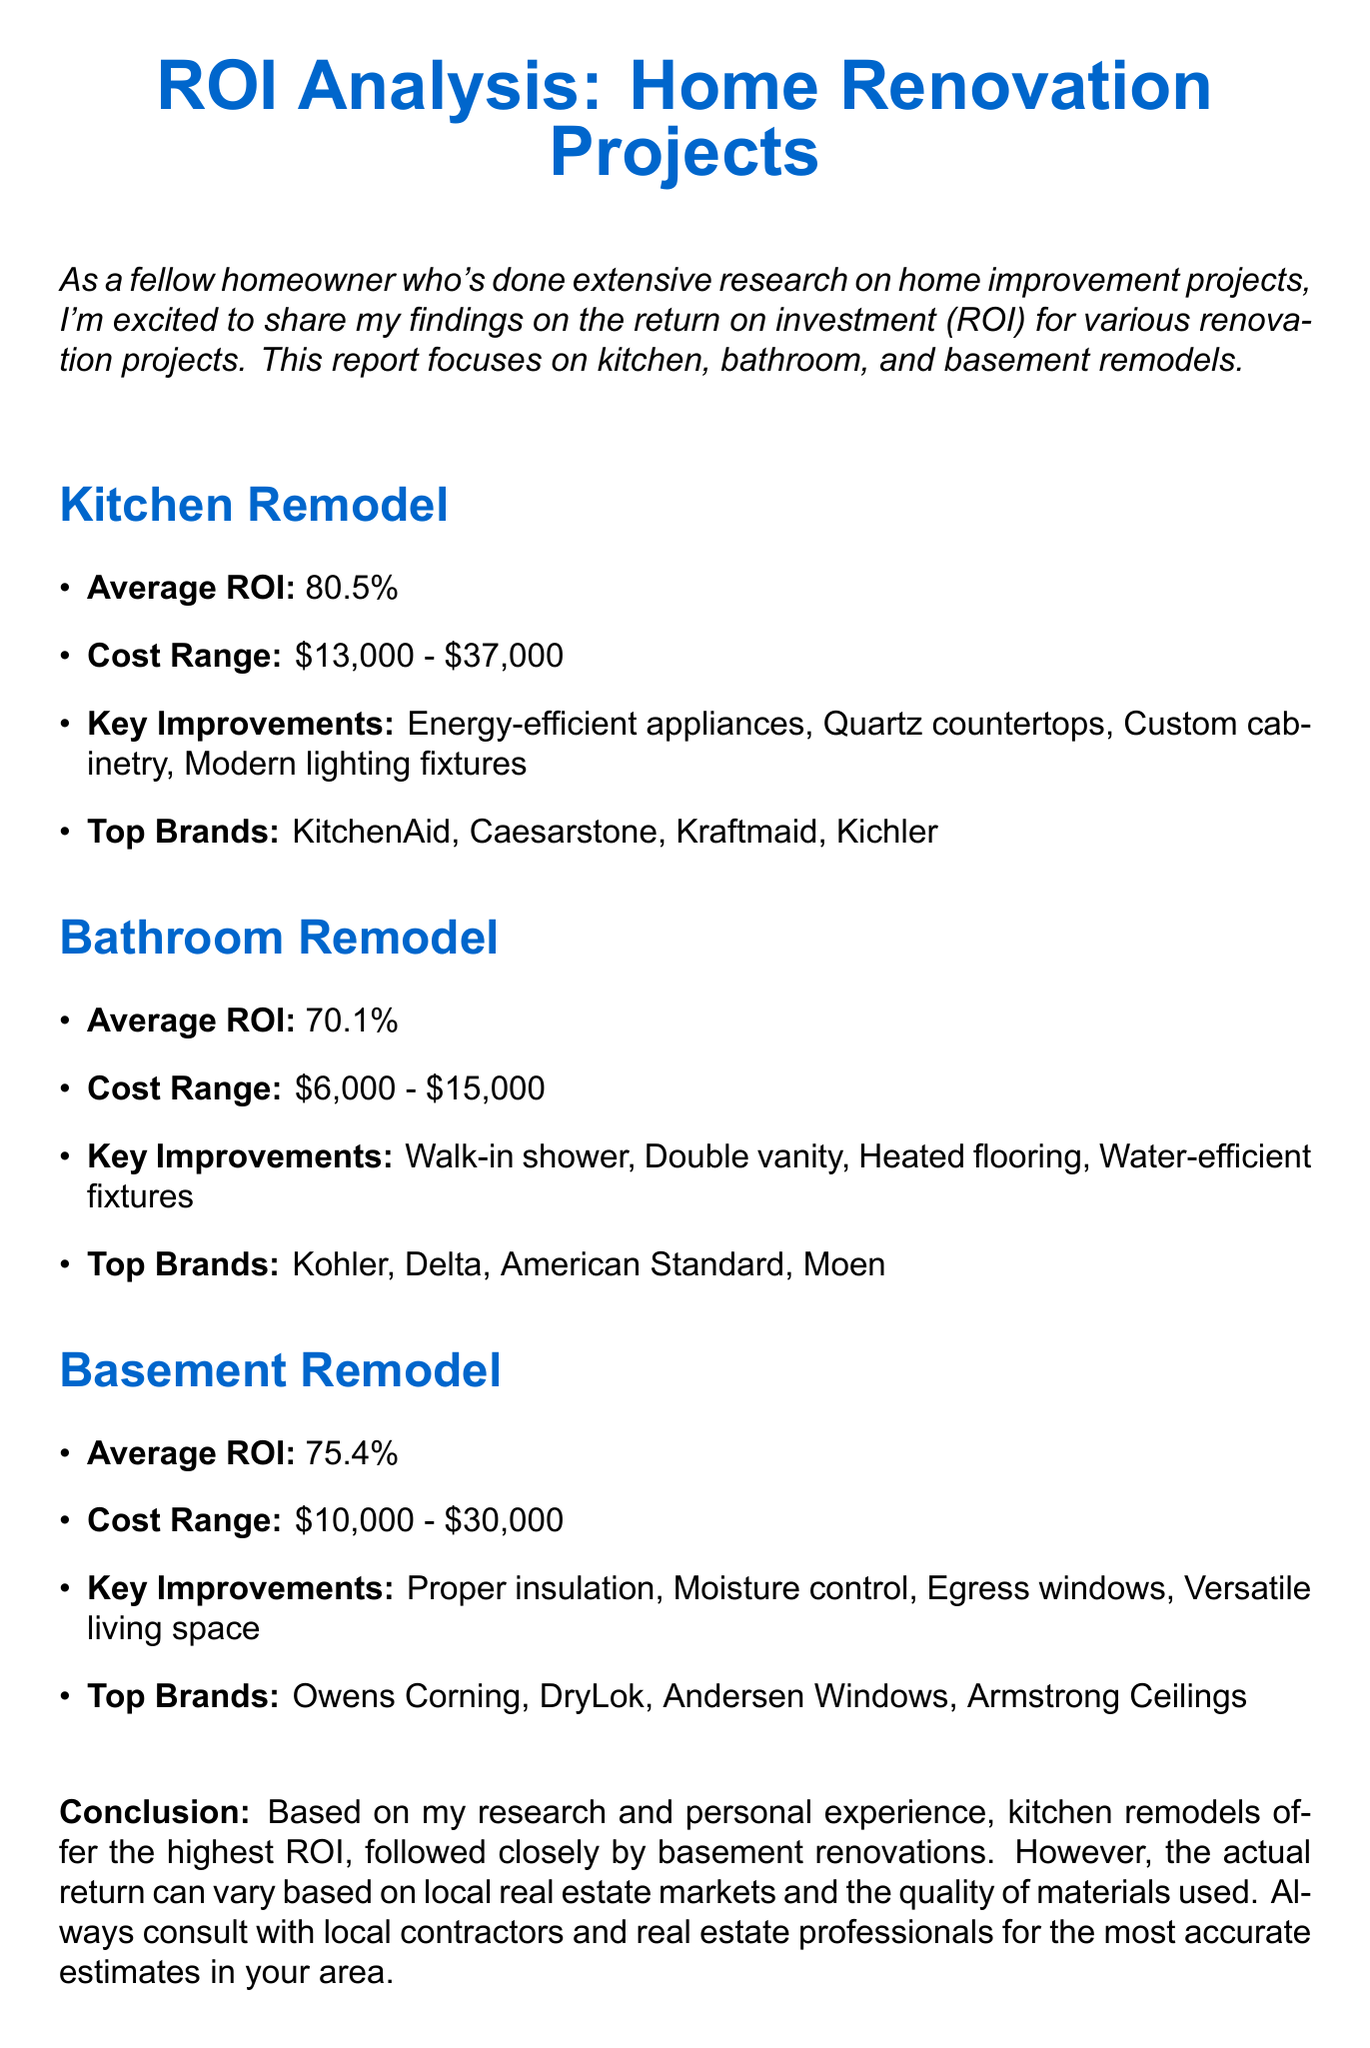What is the average ROI for a kitchen remodel? The average ROI is directly stated in the document for a kitchen remodel as 80.5%.
Answer: 80.5% What is the cost range for bathroom remodels? The document specifies the cost range for bathroom remodels as $6,000 - $15,000.
Answer: $6,000 - $15,000 List one key improvement for basement remodels. The document highlights several key improvements for basement remodels; one example is proper insulation.
Answer: Proper insulation Which brand is listed as a top brand for kitchen remodels? The document mentions several top brands for kitchen remodels, one is KitchenAid.
Answer: KitchenAid How does the average ROI for bathroom remodels compare to that of basement remodels? The average ROI for bathroom remodels (70.1%) is lower than that of basement remodels (75.4%).
Answer: Lower What is the highest average ROI among the renovation projects discussed? The document clearly states that the highest average ROI is from kitchen remodels at 80.5%.
Answer: 80.5% What conclusion is drawn regarding kitchen and basement remodels? The document concludes that kitchen remodels offer the highest ROI, followed closely by basement renovations.
Answer: Highest ROI What is one feature of energy-efficient appliances mentioned in kitchen remodels? The document refers to energy-efficient appliances as a key improvement in kitchen remodels.
Answer: Key improvement 